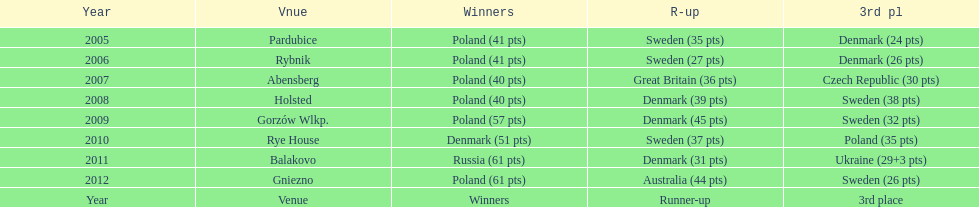Can you give me this table as a dict? {'header': ['Year', 'Vnue', 'Winners', 'R-up', '3rd pl'], 'rows': [['2005', 'Pardubice', 'Poland (41 pts)', 'Sweden (35 pts)', 'Denmark (24 pts)'], ['2006', 'Rybnik', 'Poland (41 pts)', 'Sweden (27 pts)', 'Denmark (26 pts)'], ['2007', 'Abensberg', 'Poland (40 pts)', 'Great Britain (36 pts)', 'Czech Republic (30 pts)'], ['2008', 'Holsted', 'Poland (40 pts)', 'Denmark (39 pts)', 'Sweden (38 pts)'], ['2009', 'Gorzów Wlkp.', 'Poland (57 pts)', 'Denmark (45 pts)', 'Sweden (32 pts)'], ['2010', 'Rye House', 'Denmark (51 pts)', 'Sweden (37 pts)', 'Poland (35 pts)'], ['2011', 'Balakovo', 'Russia (61 pts)', 'Denmark (31 pts)', 'Ukraine (29+3 pts)'], ['2012', 'Gniezno', 'Poland (61 pts)', 'Australia (44 pts)', 'Sweden (26 pts)'], ['Year', 'Venue', 'Winners', 'Runner-up', '3rd place']]} What was the last year 3rd place finished with less than 25 points? 2005. 